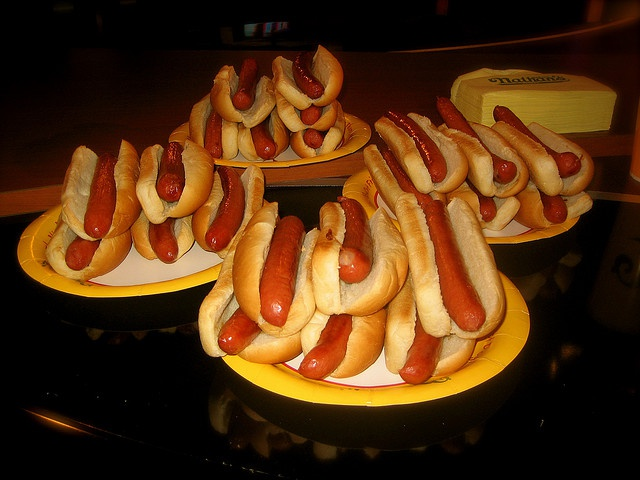Describe the objects in this image and their specific colors. I can see dining table in black, maroon, gold, and orange tones, hot dog in black, brown, and maroon tones, hot dog in black, tan, brown, red, and orange tones, hot dog in black, orange, maroon, and red tones, and hot dog in black, tan, red, khaki, and maroon tones in this image. 